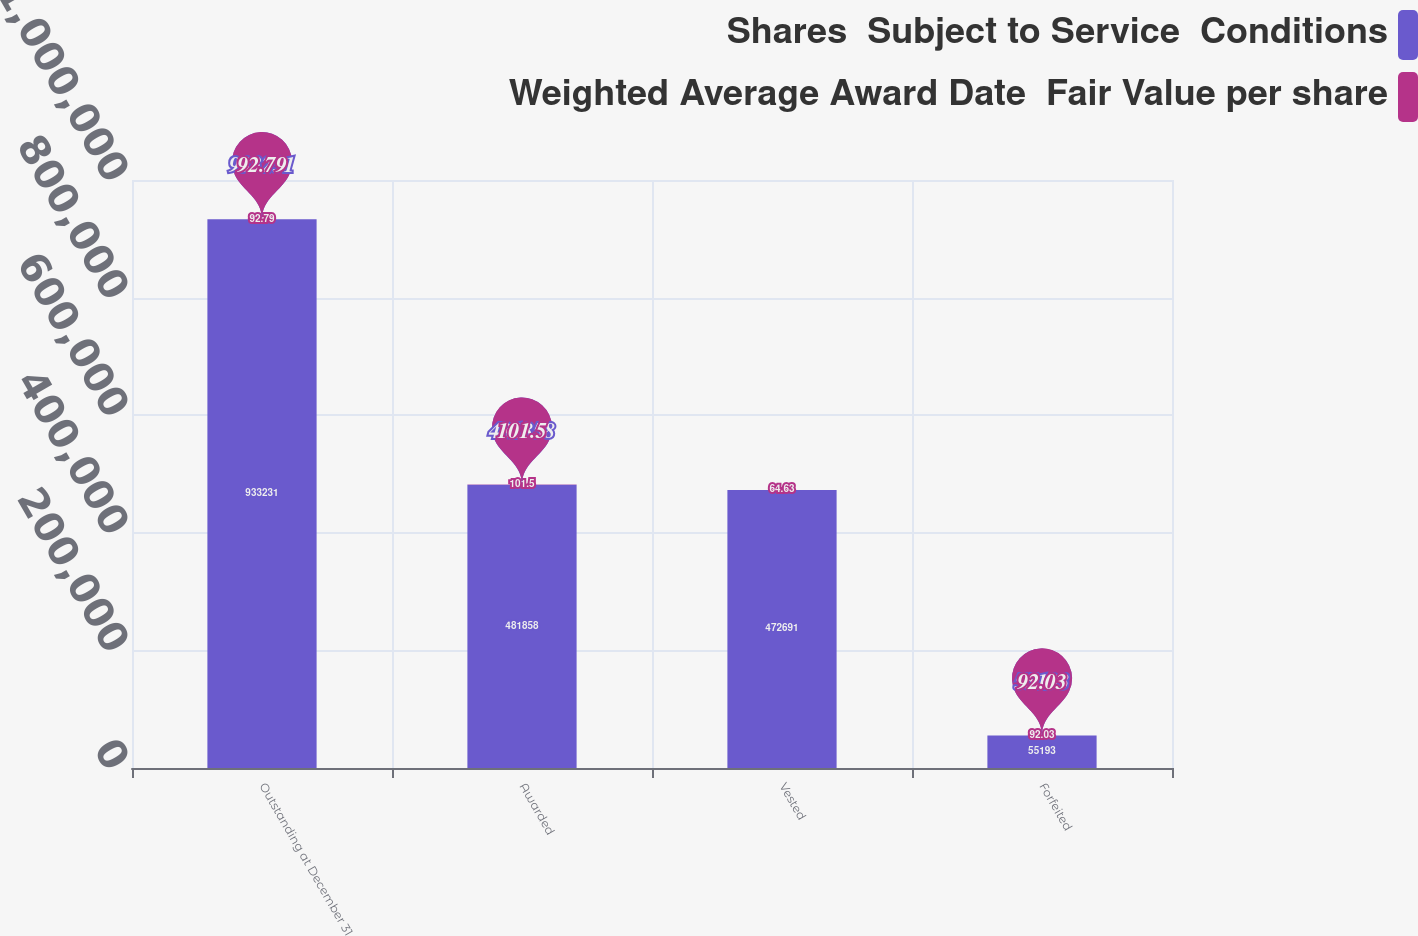<chart> <loc_0><loc_0><loc_500><loc_500><stacked_bar_chart><ecel><fcel>Outstanding at December 31<fcel>Awarded<fcel>Vested<fcel>Forfeited<nl><fcel>Shares  Subject to Service  Conditions<fcel>933231<fcel>481858<fcel>472691<fcel>55193<nl><fcel>Weighted Average Award Date  Fair Value per share<fcel>92.79<fcel>101.5<fcel>64.63<fcel>92.03<nl></chart> 